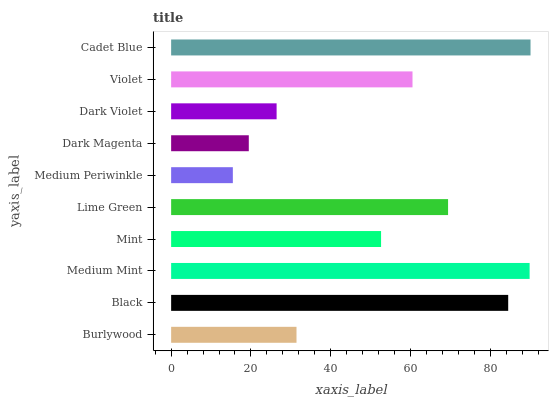Is Medium Periwinkle the minimum?
Answer yes or no. Yes. Is Cadet Blue the maximum?
Answer yes or no. Yes. Is Black the minimum?
Answer yes or no. No. Is Black the maximum?
Answer yes or no. No. Is Black greater than Burlywood?
Answer yes or no. Yes. Is Burlywood less than Black?
Answer yes or no. Yes. Is Burlywood greater than Black?
Answer yes or no. No. Is Black less than Burlywood?
Answer yes or no. No. Is Violet the high median?
Answer yes or no. Yes. Is Mint the low median?
Answer yes or no. Yes. Is Lime Green the high median?
Answer yes or no. No. Is Dark Magenta the low median?
Answer yes or no. No. 